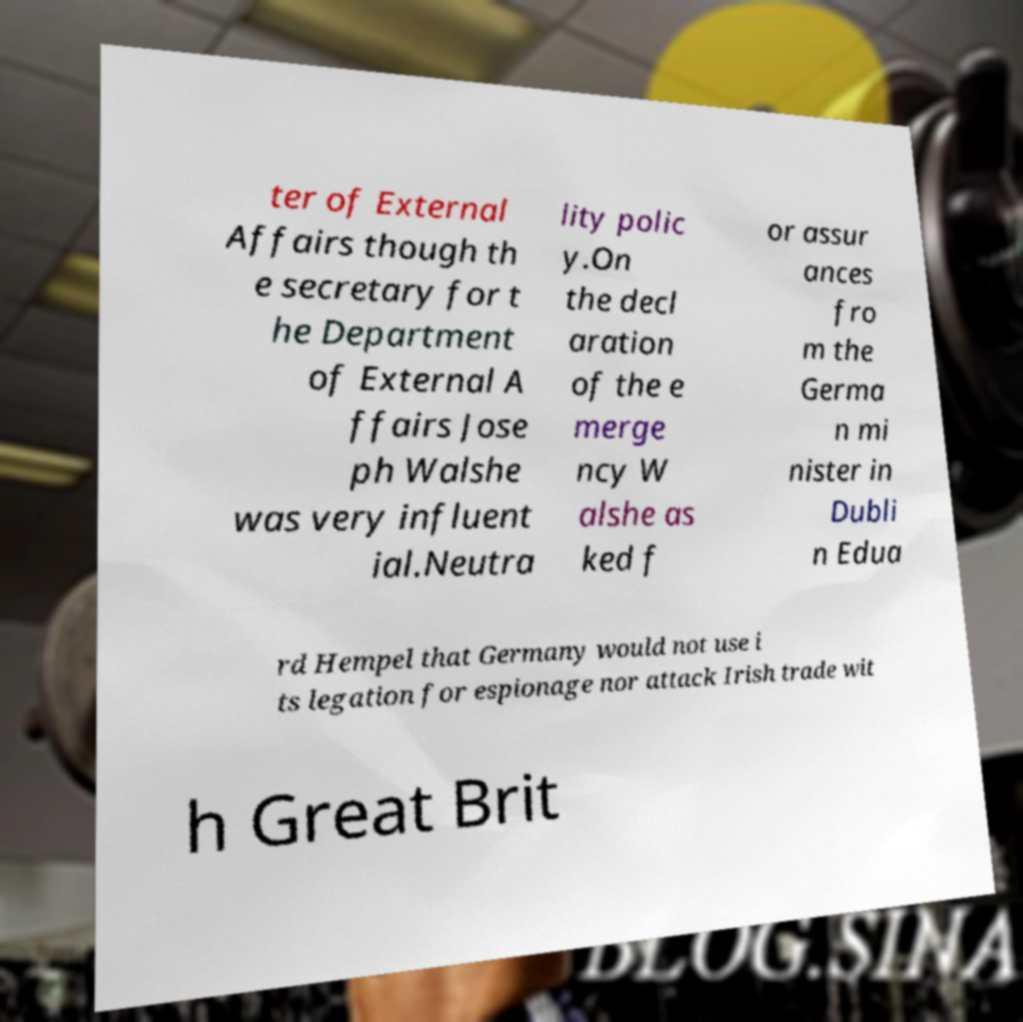Please read and relay the text visible in this image. What does it say? ter of External Affairs though th e secretary for t he Department of External A ffairs Jose ph Walshe was very influent ial.Neutra lity polic y.On the decl aration of the e merge ncy W alshe as ked f or assur ances fro m the Germa n mi nister in Dubli n Edua rd Hempel that Germany would not use i ts legation for espionage nor attack Irish trade wit h Great Brit 